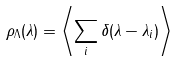<formula> <loc_0><loc_0><loc_500><loc_500>\rho _ { \Lambda } ( \lambda ) = \left < \sum _ { i } \delta ( \lambda - \lambda _ { i } ) \right ></formula> 